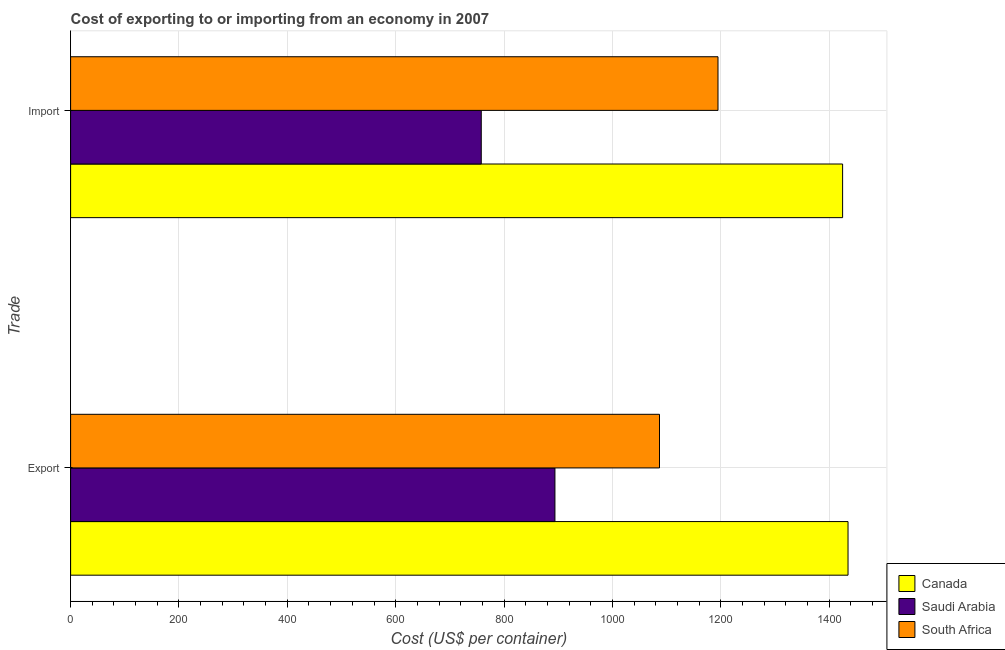How many different coloured bars are there?
Offer a terse response. 3. Are the number of bars per tick equal to the number of legend labels?
Offer a very short reply. Yes. How many bars are there on the 1st tick from the top?
Your response must be concise. 3. What is the label of the 1st group of bars from the top?
Offer a very short reply. Import. What is the export cost in South Africa?
Your response must be concise. 1087. Across all countries, what is the maximum export cost?
Your response must be concise. 1435. Across all countries, what is the minimum export cost?
Offer a very short reply. 894. In which country was the export cost maximum?
Offer a terse response. Canada. In which country was the import cost minimum?
Offer a very short reply. Saudi Arabia. What is the total export cost in the graph?
Offer a terse response. 3416. What is the difference between the import cost in South Africa and that in Saudi Arabia?
Offer a terse response. 437. What is the difference between the export cost in South Africa and the import cost in Canada?
Give a very brief answer. -338. What is the average export cost per country?
Ensure brevity in your answer.  1138.67. What is the difference between the export cost and import cost in Saudi Arabia?
Ensure brevity in your answer.  136. In how many countries, is the export cost greater than 1040 US$?
Your answer should be compact. 2. What is the ratio of the import cost in Saudi Arabia to that in Canada?
Your answer should be very brief. 0.53. Is the export cost in South Africa less than that in Saudi Arabia?
Keep it short and to the point. No. What does the 1st bar from the top in Import represents?
Provide a short and direct response. South Africa. What does the 3rd bar from the bottom in Export represents?
Your response must be concise. South Africa. How many bars are there?
Keep it short and to the point. 6. Are all the bars in the graph horizontal?
Offer a terse response. Yes. How many countries are there in the graph?
Provide a succinct answer. 3. Does the graph contain grids?
Give a very brief answer. Yes. How are the legend labels stacked?
Keep it short and to the point. Vertical. What is the title of the graph?
Make the answer very short. Cost of exporting to or importing from an economy in 2007. What is the label or title of the X-axis?
Your response must be concise. Cost (US$ per container). What is the label or title of the Y-axis?
Keep it short and to the point. Trade. What is the Cost (US$ per container) in Canada in Export?
Make the answer very short. 1435. What is the Cost (US$ per container) of Saudi Arabia in Export?
Your answer should be very brief. 894. What is the Cost (US$ per container) of South Africa in Export?
Make the answer very short. 1087. What is the Cost (US$ per container) in Canada in Import?
Offer a very short reply. 1425. What is the Cost (US$ per container) of Saudi Arabia in Import?
Make the answer very short. 758. What is the Cost (US$ per container) of South Africa in Import?
Offer a very short reply. 1195. Across all Trade, what is the maximum Cost (US$ per container) of Canada?
Your answer should be very brief. 1435. Across all Trade, what is the maximum Cost (US$ per container) of Saudi Arabia?
Give a very brief answer. 894. Across all Trade, what is the maximum Cost (US$ per container) of South Africa?
Your response must be concise. 1195. Across all Trade, what is the minimum Cost (US$ per container) of Canada?
Your response must be concise. 1425. Across all Trade, what is the minimum Cost (US$ per container) of Saudi Arabia?
Provide a succinct answer. 758. Across all Trade, what is the minimum Cost (US$ per container) of South Africa?
Give a very brief answer. 1087. What is the total Cost (US$ per container) in Canada in the graph?
Ensure brevity in your answer.  2860. What is the total Cost (US$ per container) in Saudi Arabia in the graph?
Offer a very short reply. 1652. What is the total Cost (US$ per container) in South Africa in the graph?
Offer a very short reply. 2282. What is the difference between the Cost (US$ per container) in Saudi Arabia in Export and that in Import?
Your answer should be very brief. 136. What is the difference between the Cost (US$ per container) in South Africa in Export and that in Import?
Ensure brevity in your answer.  -108. What is the difference between the Cost (US$ per container) of Canada in Export and the Cost (US$ per container) of Saudi Arabia in Import?
Offer a terse response. 677. What is the difference between the Cost (US$ per container) of Canada in Export and the Cost (US$ per container) of South Africa in Import?
Offer a very short reply. 240. What is the difference between the Cost (US$ per container) in Saudi Arabia in Export and the Cost (US$ per container) in South Africa in Import?
Make the answer very short. -301. What is the average Cost (US$ per container) in Canada per Trade?
Provide a short and direct response. 1430. What is the average Cost (US$ per container) in Saudi Arabia per Trade?
Your answer should be very brief. 826. What is the average Cost (US$ per container) in South Africa per Trade?
Your answer should be compact. 1141. What is the difference between the Cost (US$ per container) in Canada and Cost (US$ per container) in Saudi Arabia in Export?
Ensure brevity in your answer.  541. What is the difference between the Cost (US$ per container) in Canada and Cost (US$ per container) in South Africa in Export?
Your answer should be compact. 348. What is the difference between the Cost (US$ per container) in Saudi Arabia and Cost (US$ per container) in South Africa in Export?
Your answer should be very brief. -193. What is the difference between the Cost (US$ per container) in Canada and Cost (US$ per container) in Saudi Arabia in Import?
Your answer should be very brief. 667. What is the difference between the Cost (US$ per container) of Canada and Cost (US$ per container) of South Africa in Import?
Offer a very short reply. 230. What is the difference between the Cost (US$ per container) of Saudi Arabia and Cost (US$ per container) of South Africa in Import?
Provide a short and direct response. -437. What is the ratio of the Cost (US$ per container) of Saudi Arabia in Export to that in Import?
Your response must be concise. 1.18. What is the ratio of the Cost (US$ per container) of South Africa in Export to that in Import?
Offer a terse response. 0.91. What is the difference between the highest and the second highest Cost (US$ per container) in Canada?
Make the answer very short. 10. What is the difference between the highest and the second highest Cost (US$ per container) of Saudi Arabia?
Your answer should be compact. 136. What is the difference between the highest and the second highest Cost (US$ per container) in South Africa?
Make the answer very short. 108. What is the difference between the highest and the lowest Cost (US$ per container) in Canada?
Provide a succinct answer. 10. What is the difference between the highest and the lowest Cost (US$ per container) in Saudi Arabia?
Make the answer very short. 136. What is the difference between the highest and the lowest Cost (US$ per container) of South Africa?
Offer a terse response. 108. 